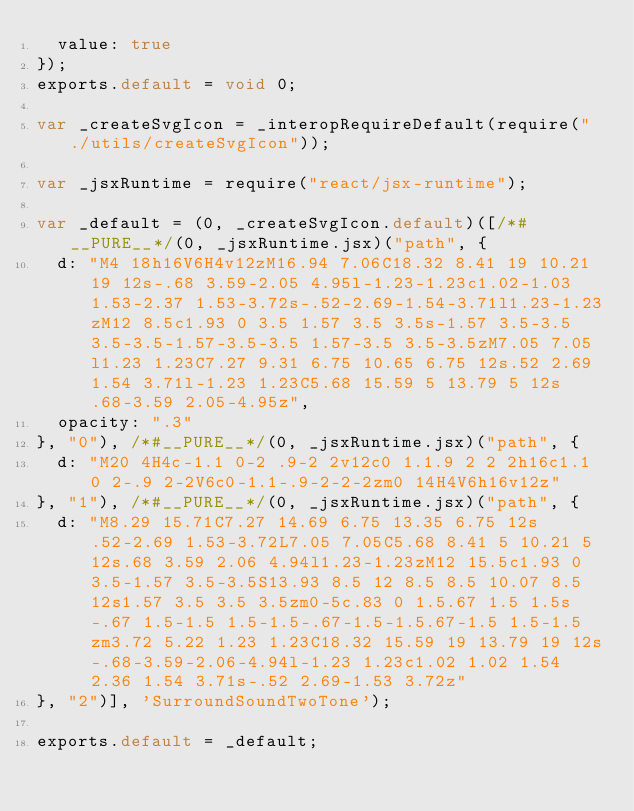<code> <loc_0><loc_0><loc_500><loc_500><_JavaScript_>  value: true
});
exports.default = void 0;

var _createSvgIcon = _interopRequireDefault(require("./utils/createSvgIcon"));

var _jsxRuntime = require("react/jsx-runtime");

var _default = (0, _createSvgIcon.default)([/*#__PURE__*/(0, _jsxRuntime.jsx)("path", {
  d: "M4 18h16V6H4v12zM16.94 7.06C18.32 8.41 19 10.21 19 12s-.68 3.59-2.05 4.95l-1.23-1.23c1.02-1.03 1.53-2.37 1.53-3.72s-.52-2.69-1.54-3.71l1.23-1.23zM12 8.5c1.93 0 3.5 1.57 3.5 3.5s-1.57 3.5-3.5 3.5-3.5-1.57-3.5-3.5 1.57-3.5 3.5-3.5zM7.05 7.05l1.23 1.23C7.27 9.31 6.75 10.65 6.75 12s.52 2.69 1.54 3.71l-1.23 1.23C5.68 15.59 5 13.79 5 12s.68-3.59 2.05-4.95z",
  opacity: ".3"
}, "0"), /*#__PURE__*/(0, _jsxRuntime.jsx)("path", {
  d: "M20 4H4c-1.1 0-2 .9-2 2v12c0 1.1.9 2 2 2h16c1.1 0 2-.9 2-2V6c0-1.1-.9-2-2-2zm0 14H4V6h16v12z"
}, "1"), /*#__PURE__*/(0, _jsxRuntime.jsx)("path", {
  d: "M8.29 15.71C7.27 14.69 6.75 13.35 6.75 12s.52-2.69 1.53-3.72L7.05 7.05C5.68 8.41 5 10.21 5 12s.68 3.59 2.06 4.94l1.23-1.23zM12 15.5c1.93 0 3.5-1.57 3.5-3.5S13.93 8.5 12 8.5 8.5 10.07 8.5 12s1.57 3.5 3.5 3.5zm0-5c.83 0 1.5.67 1.5 1.5s-.67 1.5-1.5 1.5-1.5-.67-1.5-1.5.67-1.5 1.5-1.5zm3.72 5.22 1.23 1.23C18.32 15.59 19 13.79 19 12s-.68-3.59-2.06-4.94l-1.23 1.23c1.02 1.02 1.54 2.36 1.54 3.71s-.52 2.69-1.53 3.72z"
}, "2")], 'SurroundSoundTwoTone');

exports.default = _default;</code> 